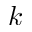Convert formula to latex. <formula><loc_0><loc_0><loc_500><loc_500>k</formula> 